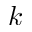Convert formula to latex. <formula><loc_0><loc_0><loc_500><loc_500>k</formula> 